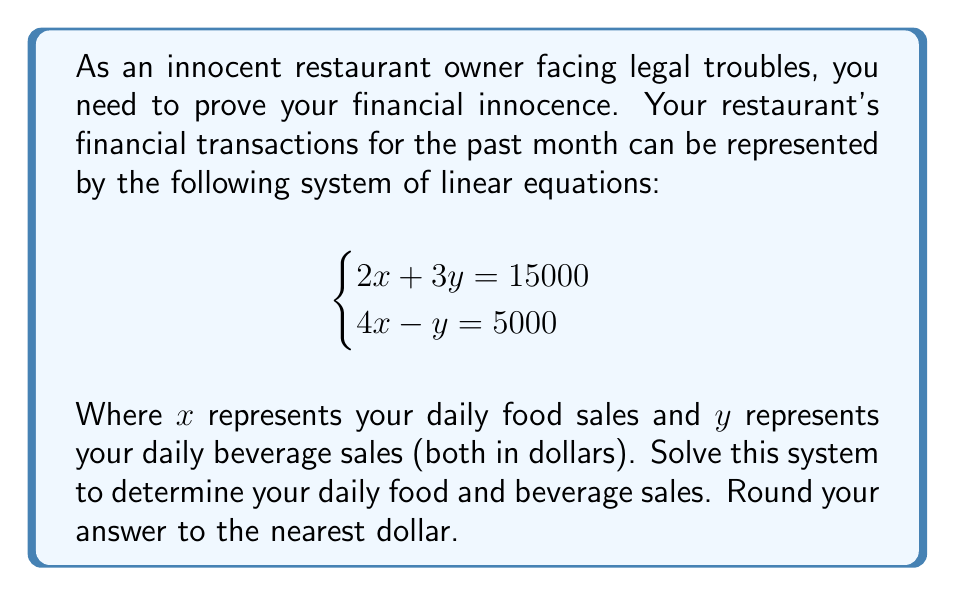Can you solve this math problem? To solve this system of linear equations, we'll use the elimination method:

1) Multiply the first equation by 2 and the second equation by 3:

   $$\begin{cases}
   4x + 6y = 30000 \\
   12x - 3y = 15000
   \end{cases}$$

2) Add the two equations to eliminate y:

   $16x + 3y = 45000$

3) Solve for x:

   $x = 45000 \div 16 = 2812.5$

4) Substitute this value of x into one of the original equations. Let's use the first one:

   $2(2812.5) + 3y = 15000$
   $5625 + 3y = 15000$
   $3y = 15000 - 5625 = 9375$
   $y = 9375 \div 3 = 3125$

5) Round the values to the nearest dollar:

   $x \approx 2813$
   $y \approx 3125$

6) Verify the solution by substituting these values into both original equations:

   Equation 1: $2(2813) + 3(3125) = 5626 + 9375 = 15001$ (off by 1 due to rounding)
   Equation 2: $4(2813) - 3125 = 11252 - 3125 = 8127 \approx 5000$ (difference due to rounding)
Answer: Daily food sales (x): $2813
Daily beverage sales (y): $3125 